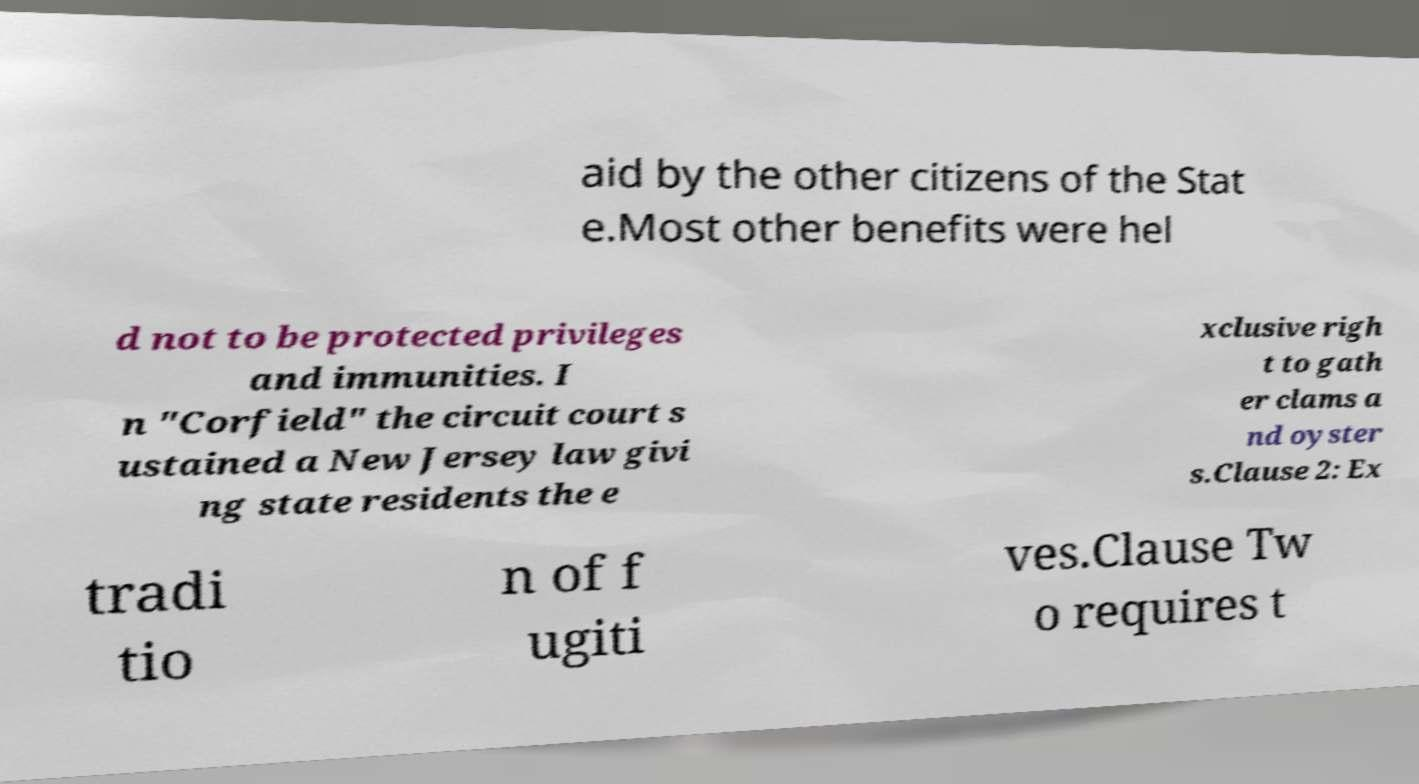Can you read and provide the text displayed in the image?This photo seems to have some interesting text. Can you extract and type it out for me? aid by the other citizens of the Stat e.Most other benefits were hel d not to be protected privileges and immunities. I n "Corfield" the circuit court s ustained a New Jersey law givi ng state residents the e xclusive righ t to gath er clams a nd oyster s.Clause 2: Ex tradi tio n of f ugiti ves.Clause Tw o requires t 